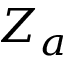<formula> <loc_0><loc_0><loc_500><loc_500>Z _ { a }</formula> 